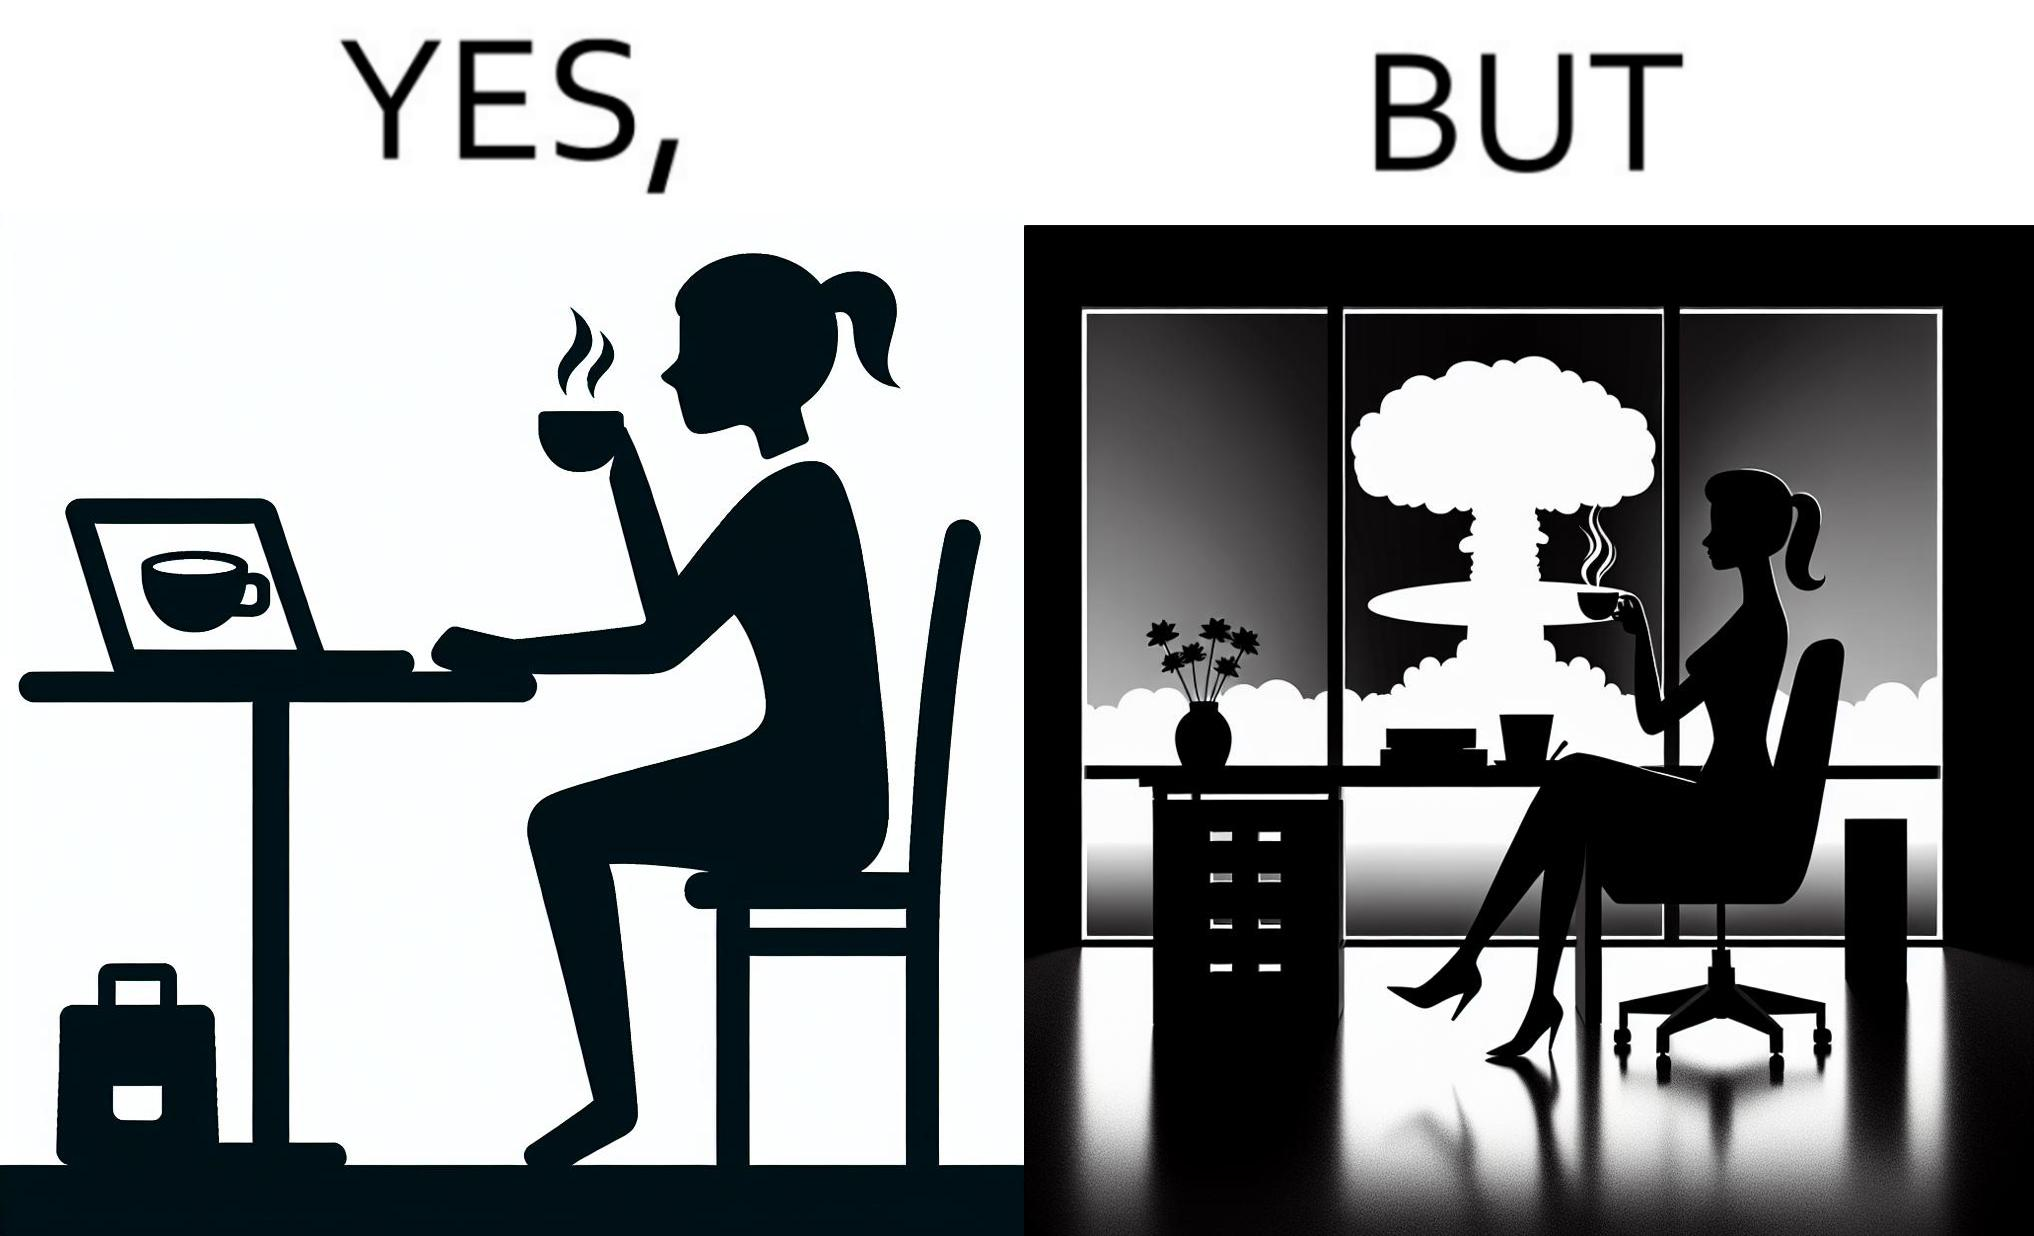What does this image depict? The images are funny since it shows a woman simply sipping from a cup at ease in a cafe with her laptop not caring about anything going on outside the cafe even though the situation is very grave,that is, a nuclear blast 